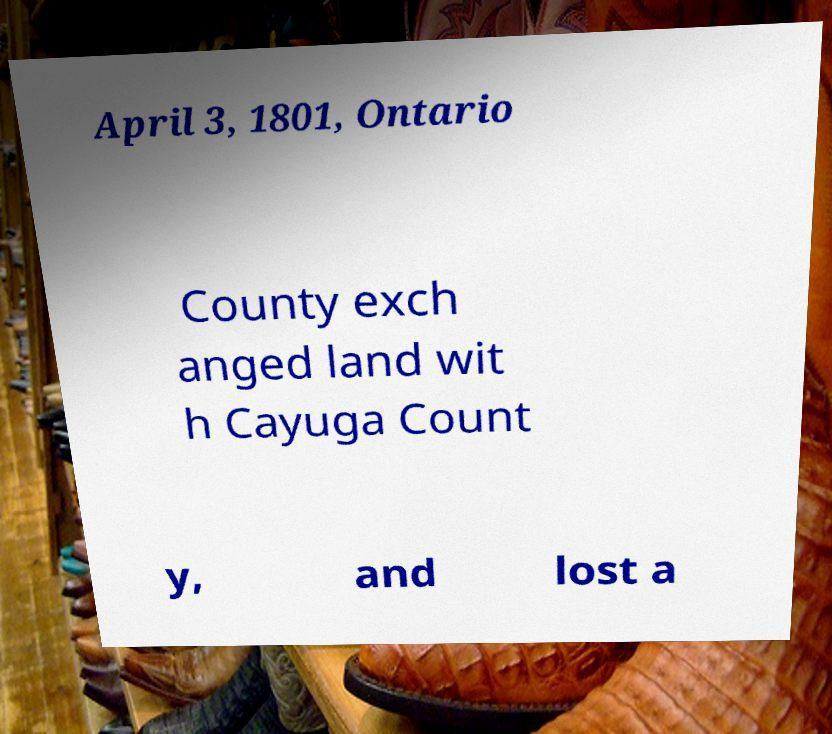Please identify and transcribe the text found in this image. April 3, 1801, Ontario County exch anged land wit h Cayuga Count y, and lost a 